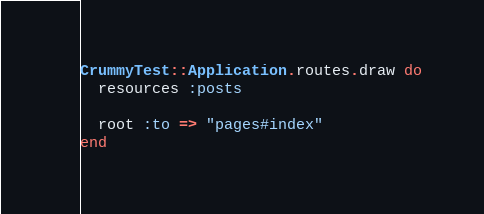Convert code to text. <code><loc_0><loc_0><loc_500><loc_500><_Ruby_>CrummyTest::Application.routes.draw do
  resources :posts
  
  root :to => "pages#index"
end
</code> 